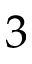<formula> <loc_0><loc_0><loc_500><loc_500>3</formula> 